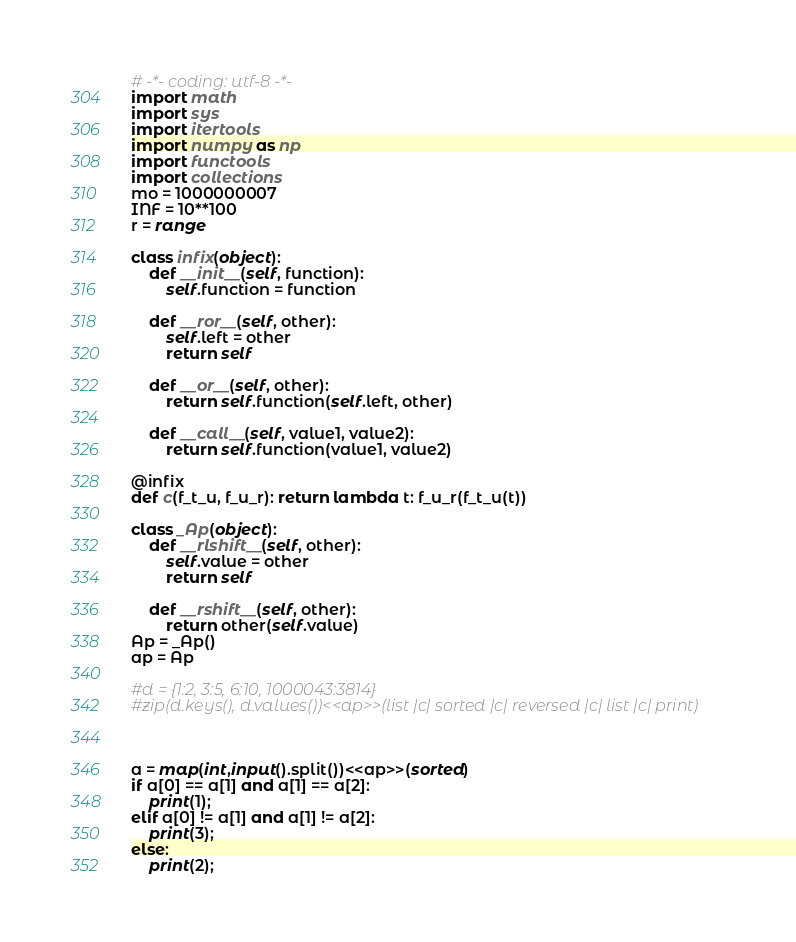Convert code to text. <code><loc_0><loc_0><loc_500><loc_500><_Python_># -*- coding: utf-8 -*-
import math
import sys
import itertools
import numpy as np
import functools
import collections
mo = 1000000007
INF = 10**100
r = range

class infix(object):
    def __init__(self, function):
        self.function = function

    def __ror__(self, other):
        self.left = other
        return self

    def __or__(self, other):
        return self.function(self.left, other)

    def __call__(self, value1, value2):
        return self.function(value1, value2)

@infix
def c(f_t_u, f_u_r): return lambda t: f_u_r(f_t_u(t))

class _Ap(object):
    def __rlshift__(self, other):
        self.value = other
        return self

    def __rshift__(self, other):
        return other(self.value)
Ap = _Ap()
ap = Ap

#d = {1:2, 3:5, 6:10, 1000043:3814}
#zip(d.keys(), d.values())<<ap>>(list |c| sorted |c| reversed |c| list |c| print)



a = map(int,input().split())<<ap>>(sorted)
if a[0] == a[1] and a[1] == a[2]:
    print(1);
elif a[0] != a[1] and a[1] != a[2]:
    print(3);
else:
    print(2);

</code> 